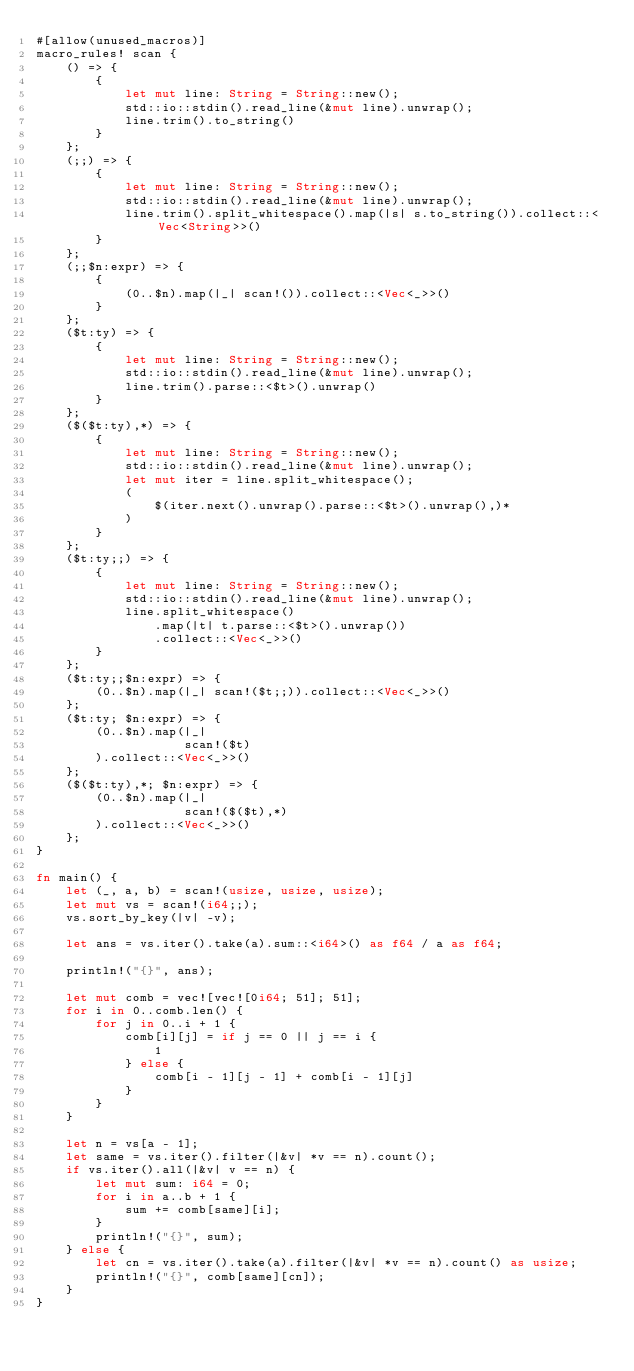<code> <loc_0><loc_0><loc_500><loc_500><_Rust_>#[allow(unused_macros)]
macro_rules! scan {
    () => {
        {
            let mut line: String = String::new();
            std::io::stdin().read_line(&mut line).unwrap();
            line.trim().to_string()
        }
    };
    (;;) => {
        {
            let mut line: String = String::new();
            std::io::stdin().read_line(&mut line).unwrap();
            line.trim().split_whitespace().map(|s| s.to_string()).collect::<Vec<String>>()
        }
    };
    (;;$n:expr) => {
        {
            (0..$n).map(|_| scan!()).collect::<Vec<_>>()
        }
    };
    ($t:ty) => {
        {
            let mut line: String = String::new();
            std::io::stdin().read_line(&mut line).unwrap();
            line.trim().parse::<$t>().unwrap()
        }
    };
    ($($t:ty),*) => {
        {
            let mut line: String = String::new();
            std::io::stdin().read_line(&mut line).unwrap();
            let mut iter = line.split_whitespace();
            (
                $(iter.next().unwrap().parse::<$t>().unwrap(),)*
            )
        }
    };
    ($t:ty;;) => {
        {
            let mut line: String = String::new();
            std::io::stdin().read_line(&mut line).unwrap();
            line.split_whitespace()
                .map(|t| t.parse::<$t>().unwrap())
                .collect::<Vec<_>>()
        }
    };
    ($t:ty;;$n:expr) => {
        (0..$n).map(|_| scan!($t;;)).collect::<Vec<_>>()
    };
    ($t:ty; $n:expr) => {
        (0..$n).map(|_|
                    scan!($t)
        ).collect::<Vec<_>>()
    };
    ($($t:ty),*; $n:expr) => {
        (0..$n).map(|_|
                    scan!($($t),*)
        ).collect::<Vec<_>>()
    };
}

fn main() {
    let (_, a, b) = scan!(usize, usize, usize);
    let mut vs = scan!(i64;;);
    vs.sort_by_key(|v| -v);

    let ans = vs.iter().take(a).sum::<i64>() as f64 / a as f64;

    println!("{}", ans);

    let mut comb = vec![vec![0i64; 51]; 51];
    for i in 0..comb.len() {
        for j in 0..i + 1 {
            comb[i][j] = if j == 0 || j == i {
                1
            } else {
                comb[i - 1][j - 1] + comb[i - 1][j]
            }
        }
    }

    let n = vs[a - 1];
    let same = vs.iter().filter(|&v| *v == n).count();
    if vs.iter().all(|&v| v == n) {
        let mut sum: i64 = 0;
        for i in a..b + 1 {
            sum += comb[same][i];
        }
        println!("{}", sum);
    } else {
        let cn = vs.iter().take(a).filter(|&v| *v == n).count() as usize;
        println!("{}", comb[same][cn]);
    }
}
</code> 